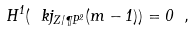<formula> <loc_0><loc_0><loc_500><loc_500>H ^ { 1 } ( \ k j _ { Z / \P P ^ { 2 } } ( m - 1 ) ) = 0 \ ,</formula> 